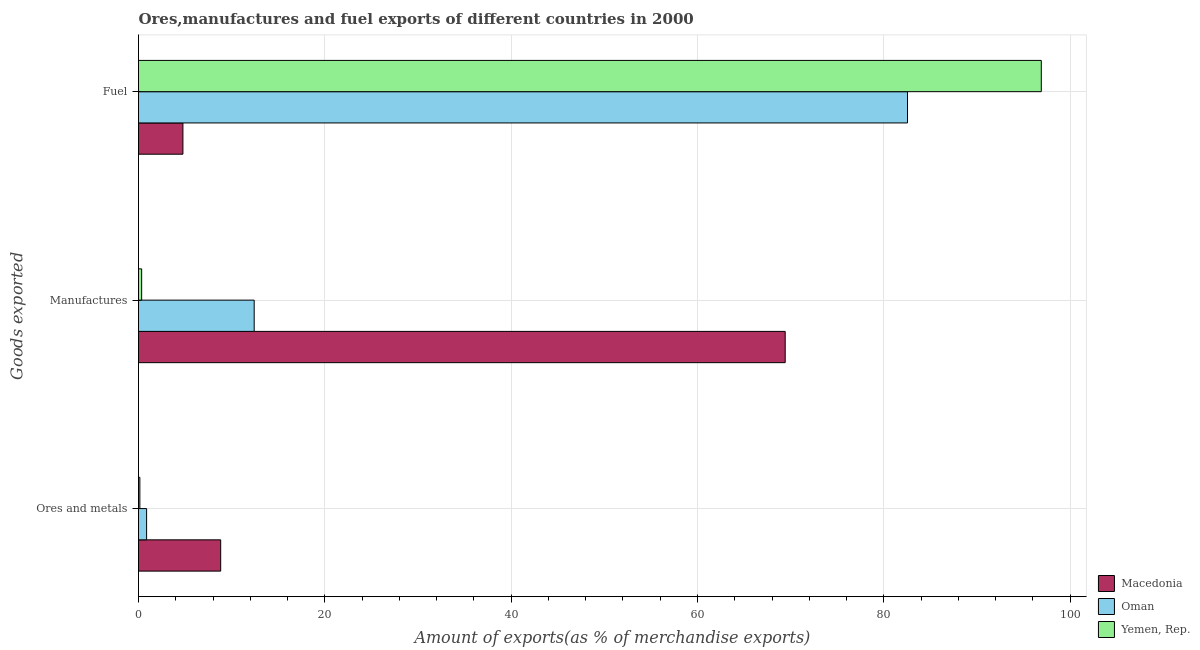How many bars are there on the 1st tick from the top?
Keep it short and to the point. 3. How many bars are there on the 3rd tick from the bottom?
Offer a terse response. 3. What is the label of the 3rd group of bars from the top?
Your response must be concise. Ores and metals. What is the percentage of ores and metals exports in Oman?
Ensure brevity in your answer.  0.87. Across all countries, what is the maximum percentage of ores and metals exports?
Make the answer very short. 8.82. Across all countries, what is the minimum percentage of manufactures exports?
Offer a very short reply. 0.34. In which country was the percentage of ores and metals exports maximum?
Provide a succinct answer. Macedonia. In which country was the percentage of ores and metals exports minimum?
Offer a terse response. Yemen, Rep. What is the total percentage of manufactures exports in the graph?
Provide a short and direct response. 82.16. What is the difference between the percentage of ores and metals exports in Yemen, Rep. and that in Oman?
Your answer should be compact. -0.72. What is the difference between the percentage of manufactures exports in Macedonia and the percentage of ores and metals exports in Oman?
Offer a terse response. 68.54. What is the average percentage of ores and metals exports per country?
Your response must be concise. 3.28. What is the difference between the percentage of manufactures exports and percentage of ores and metals exports in Yemen, Rep.?
Keep it short and to the point. 0.19. What is the ratio of the percentage of manufactures exports in Yemen, Rep. to that in Oman?
Your answer should be compact. 0.03. Is the percentage of manufactures exports in Yemen, Rep. less than that in Oman?
Your response must be concise. Yes. What is the difference between the highest and the second highest percentage of ores and metals exports?
Provide a short and direct response. 7.95. What is the difference between the highest and the lowest percentage of ores and metals exports?
Keep it short and to the point. 8.68. What does the 3rd bar from the top in Ores and metals represents?
Provide a succinct answer. Macedonia. What does the 2nd bar from the bottom in Fuel represents?
Your answer should be compact. Oman. How many countries are there in the graph?
Your response must be concise. 3. Does the graph contain any zero values?
Make the answer very short. No. Where does the legend appear in the graph?
Provide a succinct answer. Bottom right. How many legend labels are there?
Make the answer very short. 3. What is the title of the graph?
Your answer should be compact. Ores,manufactures and fuel exports of different countries in 2000. Does "Niger" appear as one of the legend labels in the graph?
Your response must be concise. No. What is the label or title of the X-axis?
Offer a terse response. Amount of exports(as % of merchandise exports). What is the label or title of the Y-axis?
Provide a succinct answer. Goods exported. What is the Amount of exports(as % of merchandise exports) of Macedonia in Ores and metals?
Your response must be concise. 8.82. What is the Amount of exports(as % of merchandise exports) of Oman in Ores and metals?
Offer a very short reply. 0.87. What is the Amount of exports(as % of merchandise exports) of Yemen, Rep. in Ores and metals?
Provide a succinct answer. 0.14. What is the Amount of exports(as % of merchandise exports) in Macedonia in Manufactures?
Your answer should be very brief. 69.41. What is the Amount of exports(as % of merchandise exports) in Oman in Manufactures?
Give a very brief answer. 12.42. What is the Amount of exports(as % of merchandise exports) in Yemen, Rep. in Manufactures?
Give a very brief answer. 0.34. What is the Amount of exports(as % of merchandise exports) in Macedonia in Fuel?
Keep it short and to the point. 4.77. What is the Amount of exports(as % of merchandise exports) of Oman in Fuel?
Your answer should be very brief. 82.54. What is the Amount of exports(as % of merchandise exports) of Yemen, Rep. in Fuel?
Offer a terse response. 96.9. Across all Goods exported, what is the maximum Amount of exports(as % of merchandise exports) in Macedonia?
Make the answer very short. 69.41. Across all Goods exported, what is the maximum Amount of exports(as % of merchandise exports) of Oman?
Offer a very short reply. 82.54. Across all Goods exported, what is the maximum Amount of exports(as % of merchandise exports) in Yemen, Rep.?
Ensure brevity in your answer.  96.9. Across all Goods exported, what is the minimum Amount of exports(as % of merchandise exports) of Macedonia?
Keep it short and to the point. 4.77. Across all Goods exported, what is the minimum Amount of exports(as % of merchandise exports) in Oman?
Your response must be concise. 0.87. Across all Goods exported, what is the minimum Amount of exports(as % of merchandise exports) in Yemen, Rep.?
Provide a succinct answer. 0.14. What is the total Amount of exports(as % of merchandise exports) in Macedonia in the graph?
Make the answer very short. 83. What is the total Amount of exports(as % of merchandise exports) of Oman in the graph?
Ensure brevity in your answer.  95.82. What is the total Amount of exports(as % of merchandise exports) of Yemen, Rep. in the graph?
Give a very brief answer. 97.38. What is the difference between the Amount of exports(as % of merchandise exports) in Macedonia in Ores and metals and that in Manufactures?
Your answer should be compact. -60.59. What is the difference between the Amount of exports(as % of merchandise exports) of Oman in Ores and metals and that in Manufactures?
Your answer should be compact. -11.55. What is the difference between the Amount of exports(as % of merchandise exports) in Yemen, Rep. in Ores and metals and that in Manufactures?
Keep it short and to the point. -0.19. What is the difference between the Amount of exports(as % of merchandise exports) in Macedonia in Ores and metals and that in Fuel?
Offer a terse response. 4.05. What is the difference between the Amount of exports(as % of merchandise exports) of Oman in Ores and metals and that in Fuel?
Ensure brevity in your answer.  -81.67. What is the difference between the Amount of exports(as % of merchandise exports) of Yemen, Rep. in Ores and metals and that in Fuel?
Your answer should be very brief. -96.75. What is the difference between the Amount of exports(as % of merchandise exports) in Macedonia in Manufactures and that in Fuel?
Make the answer very short. 64.65. What is the difference between the Amount of exports(as % of merchandise exports) in Oman in Manufactures and that in Fuel?
Your answer should be compact. -70.12. What is the difference between the Amount of exports(as % of merchandise exports) of Yemen, Rep. in Manufactures and that in Fuel?
Your answer should be very brief. -96.56. What is the difference between the Amount of exports(as % of merchandise exports) of Macedonia in Ores and metals and the Amount of exports(as % of merchandise exports) of Oman in Manufactures?
Provide a short and direct response. -3.6. What is the difference between the Amount of exports(as % of merchandise exports) of Macedonia in Ores and metals and the Amount of exports(as % of merchandise exports) of Yemen, Rep. in Manufactures?
Your response must be concise. 8.48. What is the difference between the Amount of exports(as % of merchandise exports) in Oman in Ores and metals and the Amount of exports(as % of merchandise exports) in Yemen, Rep. in Manufactures?
Provide a succinct answer. 0.53. What is the difference between the Amount of exports(as % of merchandise exports) in Macedonia in Ores and metals and the Amount of exports(as % of merchandise exports) in Oman in Fuel?
Provide a short and direct response. -73.72. What is the difference between the Amount of exports(as % of merchandise exports) in Macedonia in Ores and metals and the Amount of exports(as % of merchandise exports) in Yemen, Rep. in Fuel?
Your answer should be compact. -88.08. What is the difference between the Amount of exports(as % of merchandise exports) of Oman in Ores and metals and the Amount of exports(as % of merchandise exports) of Yemen, Rep. in Fuel?
Your response must be concise. -96.03. What is the difference between the Amount of exports(as % of merchandise exports) in Macedonia in Manufactures and the Amount of exports(as % of merchandise exports) in Oman in Fuel?
Keep it short and to the point. -13.13. What is the difference between the Amount of exports(as % of merchandise exports) of Macedonia in Manufactures and the Amount of exports(as % of merchandise exports) of Yemen, Rep. in Fuel?
Make the answer very short. -27.49. What is the difference between the Amount of exports(as % of merchandise exports) in Oman in Manufactures and the Amount of exports(as % of merchandise exports) in Yemen, Rep. in Fuel?
Your answer should be very brief. -84.48. What is the average Amount of exports(as % of merchandise exports) of Macedonia per Goods exported?
Provide a short and direct response. 27.67. What is the average Amount of exports(as % of merchandise exports) in Oman per Goods exported?
Provide a short and direct response. 31.94. What is the average Amount of exports(as % of merchandise exports) of Yemen, Rep. per Goods exported?
Give a very brief answer. 32.46. What is the difference between the Amount of exports(as % of merchandise exports) of Macedonia and Amount of exports(as % of merchandise exports) of Oman in Ores and metals?
Ensure brevity in your answer.  7.95. What is the difference between the Amount of exports(as % of merchandise exports) of Macedonia and Amount of exports(as % of merchandise exports) of Yemen, Rep. in Ores and metals?
Offer a very short reply. 8.68. What is the difference between the Amount of exports(as % of merchandise exports) in Oman and Amount of exports(as % of merchandise exports) in Yemen, Rep. in Ores and metals?
Your answer should be compact. 0.72. What is the difference between the Amount of exports(as % of merchandise exports) in Macedonia and Amount of exports(as % of merchandise exports) in Oman in Manufactures?
Offer a very short reply. 57. What is the difference between the Amount of exports(as % of merchandise exports) of Macedonia and Amount of exports(as % of merchandise exports) of Yemen, Rep. in Manufactures?
Provide a short and direct response. 69.08. What is the difference between the Amount of exports(as % of merchandise exports) of Oman and Amount of exports(as % of merchandise exports) of Yemen, Rep. in Manufactures?
Offer a terse response. 12.08. What is the difference between the Amount of exports(as % of merchandise exports) of Macedonia and Amount of exports(as % of merchandise exports) of Oman in Fuel?
Offer a terse response. -77.77. What is the difference between the Amount of exports(as % of merchandise exports) in Macedonia and Amount of exports(as % of merchandise exports) in Yemen, Rep. in Fuel?
Provide a succinct answer. -92.13. What is the difference between the Amount of exports(as % of merchandise exports) of Oman and Amount of exports(as % of merchandise exports) of Yemen, Rep. in Fuel?
Keep it short and to the point. -14.36. What is the ratio of the Amount of exports(as % of merchandise exports) of Macedonia in Ores and metals to that in Manufactures?
Offer a very short reply. 0.13. What is the ratio of the Amount of exports(as % of merchandise exports) of Oman in Ores and metals to that in Manufactures?
Your answer should be very brief. 0.07. What is the ratio of the Amount of exports(as % of merchandise exports) of Yemen, Rep. in Ores and metals to that in Manufactures?
Offer a terse response. 0.43. What is the ratio of the Amount of exports(as % of merchandise exports) of Macedonia in Ores and metals to that in Fuel?
Your answer should be compact. 1.85. What is the ratio of the Amount of exports(as % of merchandise exports) in Oman in Ores and metals to that in Fuel?
Make the answer very short. 0.01. What is the ratio of the Amount of exports(as % of merchandise exports) in Yemen, Rep. in Ores and metals to that in Fuel?
Your response must be concise. 0. What is the ratio of the Amount of exports(as % of merchandise exports) of Macedonia in Manufactures to that in Fuel?
Give a very brief answer. 14.56. What is the ratio of the Amount of exports(as % of merchandise exports) of Oman in Manufactures to that in Fuel?
Provide a short and direct response. 0.15. What is the ratio of the Amount of exports(as % of merchandise exports) of Yemen, Rep. in Manufactures to that in Fuel?
Provide a short and direct response. 0. What is the difference between the highest and the second highest Amount of exports(as % of merchandise exports) of Macedonia?
Offer a very short reply. 60.59. What is the difference between the highest and the second highest Amount of exports(as % of merchandise exports) of Oman?
Your response must be concise. 70.12. What is the difference between the highest and the second highest Amount of exports(as % of merchandise exports) in Yemen, Rep.?
Make the answer very short. 96.56. What is the difference between the highest and the lowest Amount of exports(as % of merchandise exports) of Macedonia?
Give a very brief answer. 64.65. What is the difference between the highest and the lowest Amount of exports(as % of merchandise exports) of Oman?
Provide a short and direct response. 81.67. What is the difference between the highest and the lowest Amount of exports(as % of merchandise exports) of Yemen, Rep.?
Keep it short and to the point. 96.75. 